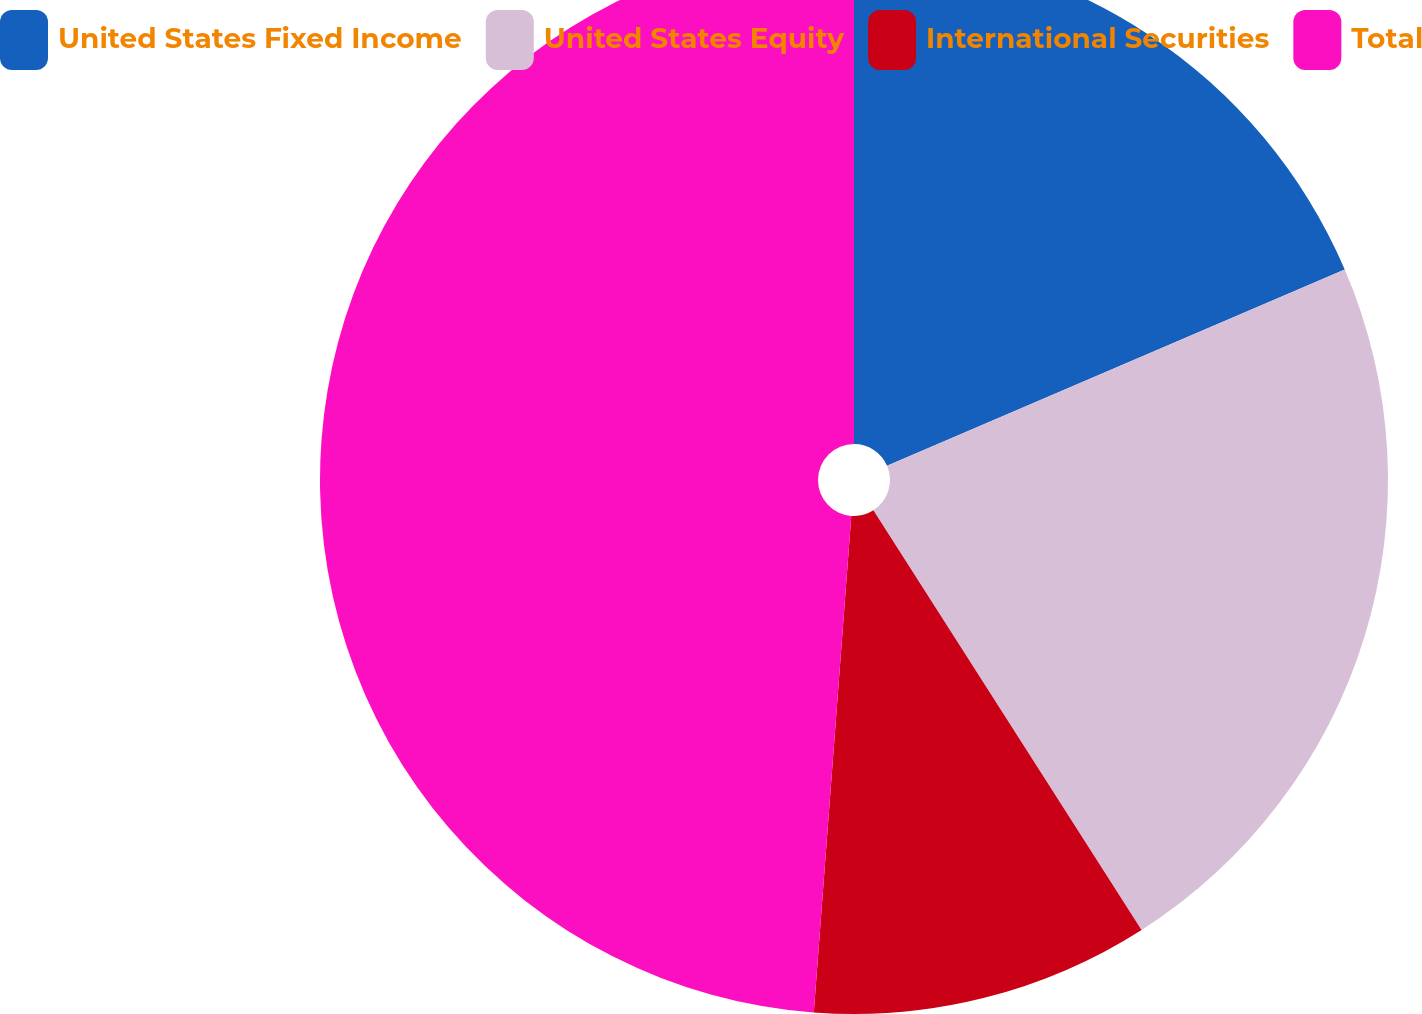<chart> <loc_0><loc_0><loc_500><loc_500><pie_chart><fcel>United States Fixed Income<fcel>United States Equity<fcel>International Securities<fcel>Total<nl><fcel>18.55%<fcel>22.4%<fcel>10.25%<fcel>48.8%<nl></chart> 